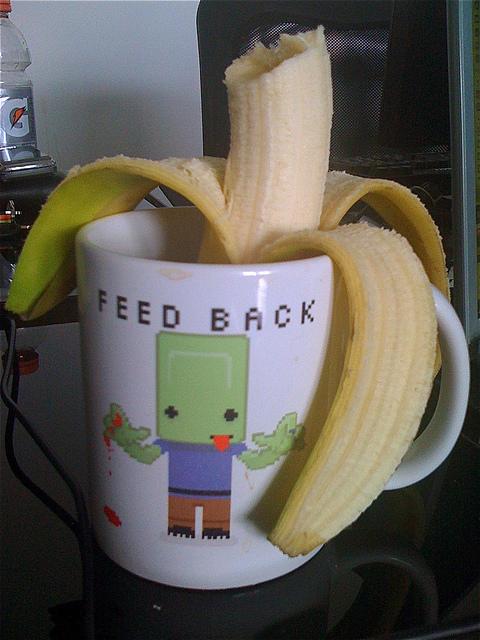Do most people use mugs to hold their bananas?
Write a very short answer. No. What does the mug say?
Short answer required. Feedback. What cartoon is on the glass?
Quick response, please. Frankenstein. What type of beverage was in the bottle in the back?
Write a very short answer. Gatorade. What's the creature on the mug?
Answer briefly. Monster. 